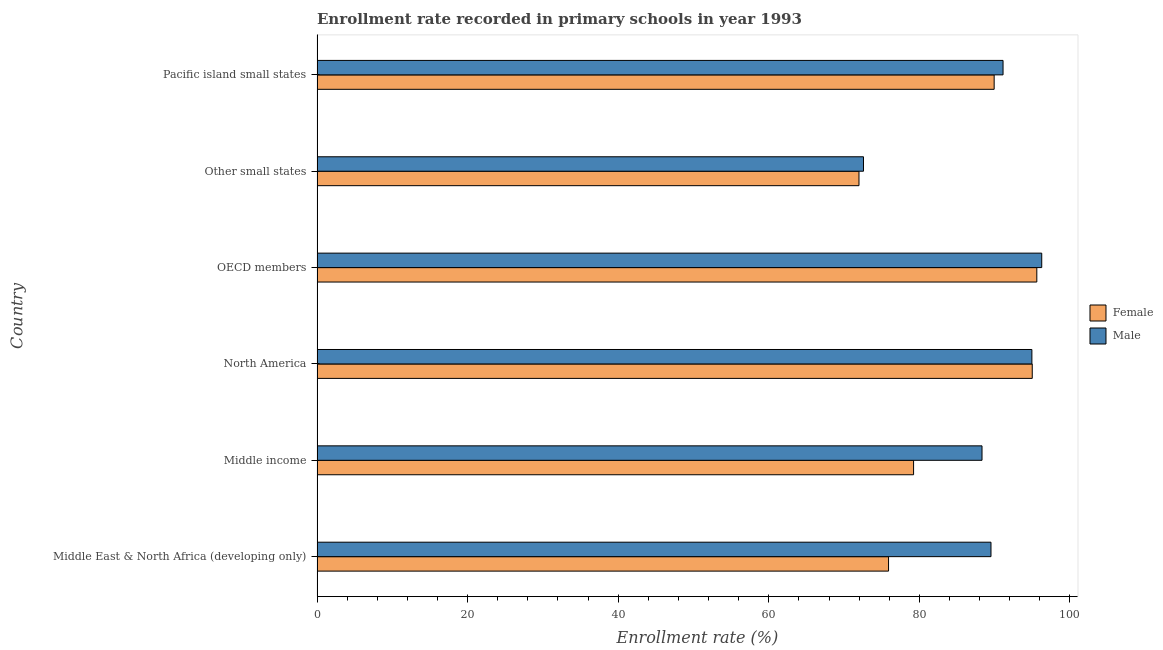How many bars are there on the 1st tick from the top?
Give a very brief answer. 2. How many bars are there on the 1st tick from the bottom?
Ensure brevity in your answer.  2. What is the label of the 6th group of bars from the top?
Offer a very short reply. Middle East & North Africa (developing only). In how many cases, is the number of bars for a given country not equal to the number of legend labels?
Make the answer very short. 0. What is the enrollment rate of male students in Middle income?
Your answer should be compact. 88.32. Across all countries, what is the maximum enrollment rate of female students?
Ensure brevity in your answer.  95.6. Across all countries, what is the minimum enrollment rate of male students?
Keep it short and to the point. 72.58. In which country was the enrollment rate of male students minimum?
Give a very brief answer. Other small states. What is the total enrollment rate of female students in the graph?
Provide a succinct answer. 507.66. What is the difference between the enrollment rate of female students in North America and that in OECD members?
Provide a succinct answer. -0.6. What is the difference between the enrollment rate of female students in OECD members and the enrollment rate of male students in Middle East & North Africa (developing only)?
Offer a terse response. 6.09. What is the average enrollment rate of male students per country?
Your answer should be very brief. 88.79. What is the difference between the enrollment rate of male students and enrollment rate of female students in Other small states?
Ensure brevity in your answer.  0.6. What is the ratio of the enrollment rate of female students in OECD members to that in Other small states?
Provide a succinct answer. 1.33. Is the enrollment rate of male students in Middle East & North Africa (developing only) less than that in Other small states?
Offer a very short reply. No. What is the difference between the highest and the second highest enrollment rate of female students?
Provide a succinct answer. 0.6. What is the difference between the highest and the lowest enrollment rate of female students?
Offer a terse response. 23.62. In how many countries, is the enrollment rate of female students greater than the average enrollment rate of female students taken over all countries?
Ensure brevity in your answer.  3. How many bars are there?
Make the answer very short. 12. Are all the bars in the graph horizontal?
Offer a very short reply. Yes. What is the difference between two consecutive major ticks on the X-axis?
Provide a succinct answer. 20. Are the values on the major ticks of X-axis written in scientific E-notation?
Give a very brief answer. No. Does the graph contain any zero values?
Make the answer very short. No. Where does the legend appear in the graph?
Your answer should be compact. Center right. How many legend labels are there?
Offer a very short reply. 2. What is the title of the graph?
Keep it short and to the point. Enrollment rate recorded in primary schools in year 1993. Does "Males" appear as one of the legend labels in the graph?
Offer a terse response. No. What is the label or title of the X-axis?
Your answer should be compact. Enrollment rate (%). What is the Enrollment rate (%) of Female in Middle East & North Africa (developing only)?
Your response must be concise. 75.91. What is the Enrollment rate (%) of Male in Middle East & North Africa (developing only)?
Your response must be concise. 89.52. What is the Enrollment rate (%) of Female in Middle income?
Your answer should be compact. 79.23. What is the Enrollment rate (%) in Male in Middle income?
Ensure brevity in your answer.  88.32. What is the Enrollment rate (%) of Female in North America?
Provide a succinct answer. 95. What is the Enrollment rate (%) in Male in North America?
Keep it short and to the point. 94.95. What is the Enrollment rate (%) of Female in OECD members?
Your answer should be very brief. 95.6. What is the Enrollment rate (%) of Male in OECD members?
Give a very brief answer. 96.26. What is the Enrollment rate (%) of Female in Other small states?
Provide a short and direct response. 71.98. What is the Enrollment rate (%) of Male in Other small states?
Your answer should be very brief. 72.58. What is the Enrollment rate (%) in Female in Pacific island small states?
Your answer should be compact. 89.94. What is the Enrollment rate (%) of Male in Pacific island small states?
Your answer should be very brief. 91.12. Across all countries, what is the maximum Enrollment rate (%) of Female?
Keep it short and to the point. 95.6. Across all countries, what is the maximum Enrollment rate (%) in Male?
Your answer should be compact. 96.26. Across all countries, what is the minimum Enrollment rate (%) in Female?
Provide a succinct answer. 71.98. Across all countries, what is the minimum Enrollment rate (%) of Male?
Ensure brevity in your answer.  72.58. What is the total Enrollment rate (%) of Female in the graph?
Ensure brevity in your answer.  507.66. What is the total Enrollment rate (%) in Male in the graph?
Provide a short and direct response. 532.74. What is the difference between the Enrollment rate (%) in Female in Middle East & North Africa (developing only) and that in Middle income?
Provide a succinct answer. -3.33. What is the difference between the Enrollment rate (%) in Male in Middle East & North Africa (developing only) and that in Middle income?
Offer a terse response. 1.19. What is the difference between the Enrollment rate (%) of Female in Middle East & North Africa (developing only) and that in North America?
Make the answer very short. -19.09. What is the difference between the Enrollment rate (%) of Male in Middle East & North Africa (developing only) and that in North America?
Make the answer very short. -5.43. What is the difference between the Enrollment rate (%) in Female in Middle East & North Africa (developing only) and that in OECD members?
Your response must be concise. -19.69. What is the difference between the Enrollment rate (%) in Male in Middle East & North Africa (developing only) and that in OECD members?
Offer a very short reply. -6.74. What is the difference between the Enrollment rate (%) of Female in Middle East & North Africa (developing only) and that in Other small states?
Offer a very short reply. 3.92. What is the difference between the Enrollment rate (%) in Male in Middle East & North Africa (developing only) and that in Other small states?
Keep it short and to the point. 16.94. What is the difference between the Enrollment rate (%) in Female in Middle East & North Africa (developing only) and that in Pacific island small states?
Your answer should be compact. -14.03. What is the difference between the Enrollment rate (%) of Male in Middle East & North Africa (developing only) and that in Pacific island small states?
Offer a terse response. -1.6. What is the difference between the Enrollment rate (%) of Female in Middle income and that in North America?
Your answer should be very brief. -15.76. What is the difference between the Enrollment rate (%) in Male in Middle income and that in North America?
Provide a succinct answer. -6.62. What is the difference between the Enrollment rate (%) of Female in Middle income and that in OECD members?
Offer a very short reply. -16.37. What is the difference between the Enrollment rate (%) of Male in Middle income and that in OECD members?
Offer a very short reply. -7.93. What is the difference between the Enrollment rate (%) in Female in Middle income and that in Other small states?
Offer a terse response. 7.25. What is the difference between the Enrollment rate (%) in Male in Middle income and that in Other small states?
Ensure brevity in your answer.  15.75. What is the difference between the Enrollment rate (%) of Female in Middle income and that in Pacific island small states?
Provide a succinct answer. -10.7. What is the difference between the Enrollment rate (%) in Male in Middle income and that in Pacific island small states?
Ensure brevity in your answer.  -2.79. What is the difference between the Enrollment rate (%) in Female in North America and that in OECD members?
Provide a short and direct response. -0.6. What is the difference between the Enrollment rate (%) in Male in North America and that in OECD members?
Keep it short and to the point. -1.31. What is the difference between the Enrollment rate (%) in Female in North America and that in Other small states?
Provide a succinct answer. 23.01. What is the difference between the Enrollment rate (%) in Male in North America and that in Other small states?
Offer a terse response. 22.37. What is the difference between the Enrollment rate (%) in Female in North America and that in Pacific island small states?
Offer a very short reply. 5.06. What is the difference between the Enrollment rate (%) in Male in North America and that in Pacific island small states?
Keep it short and to the point. 3.83. What is the difference between the Enrollment rate (%) of Female in OECD members and that in Other small states?
Offer a terse response. 23.62. What is the difference between the Enrollment rate (%) of Male in OECD members and that in Other small states?
Provide a short and direct response. 23.68. What is the difference between the Enrollment rate (%) in Female in OECD members and that in Pacific island small states?
Your answer should be compact. 5.66. What is the difference between the Enrollment rate (%) in Male in OECD members and that in Pacific island small states?
Make the answer very short. 5.14. What is the difference between the Enrollment rate (%) in Female in Other small states and that in Pacific island small states?
Provide a short and direct response. -17.95. What is the difference between the Enrollment rate (%) of Male in Other small states and that in Pacific island small states?
Offer a terse response. -18.54. What is the difference between the Enrollment rate (%) in Female in Middle East & North Africa (developing only) and the Enrollment rate (%) in Male in Middle income?
Provide a succinct answer. -12.42. What is the difference between the Enrollment rate (%) of Female in Middle East & North Africa (developing only) and the Enrollment rate (%) of Male in North America?
Ensure brevity in your answer.  -19.04. What is the difference between the Enrollment rate (%) of Female in Middle East & North Africa (developing only) and the Enrollment rate (%) of Male in OECD members?
Keep it short and to the point. -20.35. What is the difference between the Enrollment rate (%) of Female in Middle East & North Africa (developing only) and the Enrollment rate (%) of Male in Other small states?
Provide a succinct answer. 3.33. What is the difference between the Enrollment rate (%) in Female in Middle East & North Africa (developing only) and the Enrollment rate (%) in Male in Pacific island small states?
Make the answer very short. -15.21. What is the difference between the Enrollment rate (%) in Female in Middle income and the Enrollment rate (%) in Male in North America?
Provide a succinct answer. -15.71. What is the difference between the Enrollment rate (%) of Female in Middle income and the Enrollment rate (%) of Male in OECD members?
Provide a succinct answer. -17.02. What is the difference between the Enrollment rate (%) in Female in Middle income and the Enrollment rate (%) in Male in Other small states?
Offer a very short reply. 6.65. What is the difference between the Enrollment rate (%) of Female in Middle income and the Enrollment rate (%) of Male in Pacific island small states?
Provide a succinct answer. -11.88. What is the difference between the Enrollment rate (%) in Female in North America and the Enrollment rate (%) in Male in OECD members?
Provide a short and direct response. -1.26. What is the difference between the Enrollment rate (%) in Female in North America and the Enrollment rate (%) in Male in Other small states?
Make the answer very short. 22.42. What is the difference between the Enrollment rate (%) in Female in North America and the Enrollment rate (%) in Male in Pacific island small states?
Your answer should be compact. 3.88. What is the difference between the Enrollment rate (%) of Female in OECD members and the Enrollment rate (%) of Male in Other small states?
Your answer should be compact. 23.02. What is the difference between the Enrollment rate (%) of Female in OECD members and the Enrollment rate (%) of Male in Pacific island small states?
Offer a terse response. 4.48. What is the difference between the Enrollment rate (%) of Female in Other small states and the Enrollment rate (%) of Male in Pacific island small states?
Give a very brief answer. -19.13. What is the average Enrollment rate (%) of Female per country?
Offer a terse response. 84.61. What is the average Enrollment rate (%) of Male per country?
Ensure brevity in your answer.  88.79. What is the difference between the Enrollment rate (%) of Female and Enrollment rate (%) of Male in Middle East & North Africa (developing only)?
Provide a succinct answer. -13.61. What is the difference between the Enrollment rate (%) of Female and Enrollment rate (%) of Male in Middle income?
Give a very brief answer. -9.09. What is the difference between the Enrollment rate (%) in Female and Enrollment rate (%) in Male in North America?
Offer a very short reply. 0.05. What is the difference between the Enrollment rate (%) of Female and Enrollment rate (%) of Male in OECD members?
Your response must be concise. -0.66. What is the difference between the Enrollment rate (%) of Female and Enrollment rate (%) of Male in Other small states?
Your answer should be compact. -0.6. What is the difference between the Enrollment rate (%) of Female and Enrollment rate (%) of Male in Pacific island small states?
Your answer should be compact. -1.18. What is the ratio of the Enrollment rate (%) of Female in Middle East & North Africa (developing only) to that in Middle income?
Provide a short and direct response. 0.96. What is the ratio of the Enrollment rate (%) in Male in Middle East & North Africa (developing only) to that in Middle income?
Your response must be concise. 1.01. What is the ratio of the Enrollment rate (%) in Female in Middle East & North Africa (developing only) to that in North America?
Offer a terse response. 0.8. What is the ratio of the Enrollment rate (%) in Male in Middle East & North Africa (developing only) to that in North America?
Offer a very short reply. 0.94. What is the ratio of the Enrollment rate (%) of Female in Middle East & North Africa (developing only) to that in OECD members?
Make the answer very short. 0.79. What is the ratio of the Enrollment rate (%) in Female in Middle East & North Africa (developing only) to that in Other small states?
Offer a terse response. 1.05. What is the ratio of the Enrollment rate (%) in Male in Middle East & North Africa (developing only) to that in Other small states?
Provide a short and direct response. 1.23. What is the ratio of the Enrollment rate (%) of Female in Middle East & North Africa (developing only) to that in Pacific island small states?
Ensure brevity in your answer.  0.84. What is the ratio of the Enrollment rate (%) in Male in Middle East & North Africa (developing only) to that in Pacific island small states?
Make the answer very short. 0.98. What is the ratio of the Enrollment rate (%) of Female in Middle income to that in North America?
Make the answer very short. 0.83. What is the ratio of the Enrollment rate (%) in Male in Middle income to that in North America?
Your answer should be very brief. 0.93. What is the ratio of the Enrollment rate (%) of Female in Middle income to that in OECD members?
Your answer should be very brief. 0.83. What is the ratio of the Enrollment rate (%) in Male in Middle income to that in OECD members?
Your response must be concise. 0.92. What is the ratio of the Enrollment rate (%) in Female in Middle income to that in Other small states?
Offer a very short reply. 1.1. What is the ratio of the Enrollment rate (%) in Male in Middle income to that in Other small states?
Give a very brief answer. 1.22. What is the ratio of the Enrollment rate (%) of Female in Middle income to that in Pacific island small states?
Keep it short and to the point. 0.88. What is the ratio of the Enrollment rate (%) in Male in Middle income to that in Pacific island small states?
Offer a terse response. 0.97. What is the ratio of the Enrollment rate (%) of Female in North America to that in OECD members?
Your answer should be compact. 0.99. What is the ratio of the Enrollment rate (%) in Male in North America to that in OECD members?
Ensure brevity in your answer.  0.99. What is the ratio of the Enrollment rate (%) of Female in North America to that in Other small states?
Give a very brief answer. 1.32. What is the ratio of the Enrollment rate (%) in Male in North America to that in Other small states?
Provide a succinct answer. 1.31. What is the ratio of the Enrollment rate (%) in Female in North America to that in Pacific island small states?
Offer a very short reply. 1.06. What is the ratio of the Enrollment rate (%) of Male in North America to that in Pacific island small states?
Your response must be concise. 1.04. What is the ratio of the Enrollment rate (%) of Female in OECD members to that in Other small states?
Your answer should be very brief. 1.33. What is the ratio of the Enrollment rate (%) in Male in OECD members to that in Other small states?
Give a very brief answer. 1.33. What is the ratio of the Enrollment rate (%) of Female in OECD members to that in Pacific island small states?
Provide a succinct answer. 1.06. What is the ratio of the Enrollment rate (%) of Male in OECD members to that in Pacific island small states?
Offer a very short reply. 1.06. What is the ratio of the Enrollment rate (%) in Female in Other small states to that in Pacific island small states?
Make the answer very short. 0.8. What is the ratio of the Enrollment rate (%) in Male in Other small states to that in Pacific island small states?
Ensure brevity in your answer.  0.8. What is the difference between the highest and the second highest Enrollment rate (%) of Female?
Your response must be concise. 0.6. What is the difference between the highest and the second highest Enrollment rate (%) in Male?
Your response must be concise. 1.31. What is the difference between the highest and the lowest Enrollment rate (%) of Female?
Your answer should be compact. 23.62. What is the difference between the highest and the lowest Enrollment rate (%) of Male?
Offer a very short reply. 23.68. 